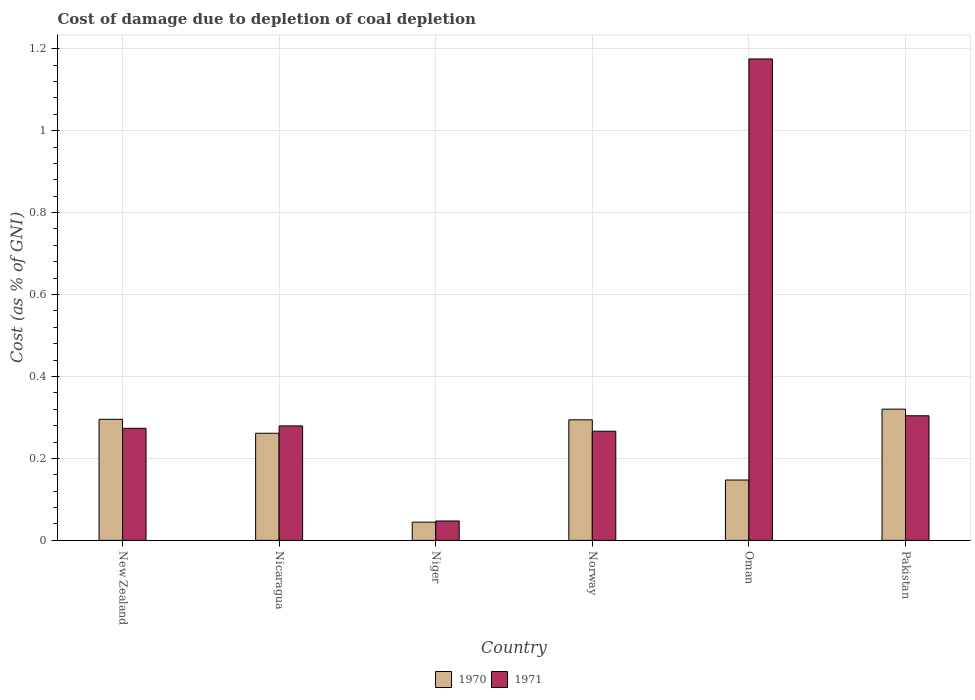How many groups of bars are there?
Provide a short and direct response. 6. Are the number of bars on each tick of the X-axis equal?
Offer a terse response. Yes. What is the label of the 5th group of bars from the left?
Offer a very short reply. Oman. What is the cost of damage caused due to coal depletion in 1970 in Pakistan?
Offer a terse response. 0.32. Across all countries, what is the maximum cost of damage caused due to coal depletion in 1970?
Give a very brief answer. 0.32. Across all countries, what is the minimum cost of damage caused due to coal depletion in 1971?
Your answer should be compact. 0.05. In which country was the cost of damage caused due to coal depletion in 1971 maximum?
Your response must be concise. Oman. In which country was the cost of damage caused due to coal depletion in 1970 minimum?
Ensure brevity in your answer.  Niger. What is the total cost of damage caused due to coal depletion in 1971 in the graph?
Make the answer very short. 2.35. What is the difference between the cost of damage caused due to coal depletion in 1971 in Norway and that in Pakistan?
Make the answer very short. -0.04. What is the difference between the cost of damage caused due to coal depletion in 1970 in Norway and the cost of damage caused due to coal depletion in 1971 in Niger?
Ensure brevity in your answer.  0.25. What is the average cost of damage caused due to coal depletion in 1971 per country?
Your answer should be compact. 0.39. What is the difference between the cost of damage caused due to coal depletion of/in 1971 and cost of damage caused due to coal depletion of/in 1970 in New Zealand?
Provide a succinct answer. -0.02. What is the ratio of the cost of damage caused due to coal depletion in 1970 in Nicaragua to that in Pakistan?
Give a very brief answer. 0.82. Is the cost of damage caused due to coal depletion in 1970 in Niger less than that in Pakistan?
Your answer should be very brief. Yes. What is the difference between the highest and the second highest cost of damage caused due to coal depletion in 1970?
Offer a very short reply. 0.02. What is the difference between the highest and the lowest cost of damage caused due to coal depletion in 1971?
Your answer should be compact. 1.13. What does the 2nd bar from the left in Niger represents?
Give a very brief answer. 1971. How many bars are there?
Your answer should be compact. 12. What is the difference between two consecutive major ticks on the Y-axis?
Your answer should be very brief. 0.2. Are the values on the major ticks of Y-axis written in scientific E-notation?
Provide a short and direct response. No. How many legend labels are there?
Keep it short and to the point. 2. What is the title of the graph?
Provide a short and direct response. Cost of damage due to depletion of coal depletion. Does "1974" appear as one of the legend labels in the graph?
Ensure brevity in your answer.  No. What is the label or title of the Y-axis?
Provide a short and direct response. Cost (as % of GNI). What is the Cost (as % of GNI) in 1970 in New Zealand?
Offer a terse response. 0.3. What is the Cost (as % of GNI) in 1971 in New Zealand?
Your answer should be compact. 0.27. What is the Cost (as % of GNI) of 1970 in Nicaragua?
Offer a terse response. 0.26. What is the Cost (as % of GNI) in 1971 in Nicaragua?
Provide a succinct answer. 0.28. What is the Cost (as % of GNI) in 1970 in Niger?
Your response must be concise. 0.04. What is the Cost (as % of GNI) in 1971 in Niger?
Keep it short and to the point. 0.05. What is the Cost (as % of GNI) in 1970 in Norway?
Your response must be concise. 0.29. What is the Cost (as % of GNI) in 1971 in Norway?
Your answer should be compact. 0.27. What is the Cost (as % of GNI) in 1970 in Oman?
Offer a very short reply. 0.15. What is the Cost (as % of GNI) of 1971 in Oman?
Give a very brief answer. 1.17. What is the Cost (as % of GNI) of 1970 in Pakistan?
Provide a short and direct response. 0.32. What is the Cost (as % of GNI) in 1971 in Pakistan?
Provide a succinct answer. 0.3. Across all countries, what is the maximum Cost (as % of GNI) of 1970?
Ensure brevity in your answer.  0.32. Across all countries, what is the maximum Cost (as % of GNI) of 1971?
Your answer should be compact. 1.17. Across all countries, what is the minimum Cost (as % of GNI) of 1970?
Offer a very short reply. 0.04. Across all countries, what is the minimum Cost (as % of GNI) of 1971?
Your answer should be very brief. 0.05. What is the total Cost (as % of GNI) in 1970 in the graph?
Provide a succinct answer. 1.36. What is the total Cost (as % of GNI) of 1971 in the graph?
Offer a very short reply. 2.35. What is the difference between the Cost (as % of GNI) of 1970 in New Zealand and that in Nicaragua?
Make the answer very short. 0.03. What is the difference between the Cost (as % of GNI) in 1971 in New Zealand and that in Nicaragua?
Ensure brevity in your answer.  -0.01. What is the difference between the Cost (as % of GNI) in 1970 in New Zealand and that in Niger?
Your response must be concise. 0.25. What is the difference between the Cost (as % of GNI) of 1971 in New Zealand and that in Niger?
Offer a very short reply. 0.23. What is the difference between the Cost (as % of GNI) in 1970 in New Zealand and that in Norway?
Make the answer very short. 0. What is the difference between the Cost (as % of GNI) in 1971 in New Zealand and that in Norway?
Make the answer very short. 0.01. What is the difference between the Cost (as % of GNI) in 1970 in New Zealand and that in Oman?
Make the answer very short. 0.15. What is the difference between the Cost (as % of GNI) in 1971 in New Zealand and that in Oman?
Keep it short and to the point. -0.9. What is the difference between the Cost (as % of GNI) of 1970 in New Zealand and that in Pakistan?
Provide a short and direct response. -0.02. What is the difference between the Cost (as % of GNI) in 1971 in New Zealand and that in Pakistan?
Offer a very short reply. -0.03. What is the difference between the Cost (as % of GNI) of 1970 in Nicaragua and that in Niger?
Your answer should be compact. 0.22. What is the difference between the Cost (as % of GNI) in 1971 in Nicaragua and that in Niger?
Give a very brief answer. 0.23. What is the difference between the Cost (as % of GNI) of 1970 in Nicaragua and that in Norway?
Give a very brief answer. -0.03. What is the difference between the Cost (as % of GNI) in 1971 in Nicaragua and that in Norway?
Give a very brief answer. 0.01. What is the difference between the Cost (as % of GNI) in 1970 in Nicaragua and that in Oman?
Your answer should be very brief. 0.11. What is the difference between the Cost (as % of GNI) of 1971 in Nicaragua and that in Oman?
Provide a succinct answer. -0.9. What is the difference between the Cost (as % of GNI) in 1970 in Nicaragua and that in Pakistan?
Provide a short and direct response. -0.06. What is the difference between the Cost (as % of GNI) of 1971 in Nicaragua and that in Pakistan?
Provide a short and direct response. -0.02. What is the difference between the Cost (as % of GNI) of 1970 in Niger and that in Norway?
Give a very brief answer. -0.25. What is the difference between the Cost (as % of GNI) in 1971 in Niger and that in Norway?
Your answer should be very brief. -0.22. What is the difference between the Cost (as % of GNI) of 1970 in Niger and that in Oman?
Your answer should be compact. -0.1. What is the difference between the Cost (as % of GNI) of 1971 in Niger and that in Oman?
Your answer should be very brief. -1.13. What is the difference between the Cost (as % of GNI) in 1970 in Niger and that in Pakistan?
Your answer should be compact. -0.28. What is the difference between the Cost (as % of GNI) of 1971 in Niger and that in Pakistan?
Make the answer very short. -0.26. What is the difference between the Cost (as % of GNI) of 1970 in Norway and that in Oman?
Provide a succinct answer. 0.15. What is the difference between the Cost (as % of GNI) of 1971 in Norway and that in Oman?
Your answer should be compact. -0.91. What is the difference between the Cost (as % of GNI) in 1970 in Norway and that in Pakistan?
Make the answer very short. -0.03. What is the difference between the Cost (as % of GNI) of 1971 in Norway and that in Pakistan?
Your answer should be very brief. -0.04. What is the difference between the Cost (as % of GNI) in 1970 in Oman and that in Pakistan?
Provide a succinct answer. -0.17. What is the difference between the Cost (as % of GNI) in 1971 in Oman and that in Pakistan?
Make the answer very short. 0.87. What is the difference between the Cost (as % of GNI) in 1970 in New Zealand and the Cost (as % of GNI) in 1971 in Nicaragua?
Provide a short and direct response. 0.02. What is the difference between the Cost (as % of GNI) of 1970 in New Zealand and the Cost (as % of GNI) of 1971 in Niger?
Provide a short and direct response. 0.25. What is the difference between the Cost (as % of GNI) in 1970 in New Zealand and the Cost (as % of GNI) in 1971 in Norway?
Your answer should be very brief. 0.03. What is the difference between the Cost (as % of GNI) in 1970 in New Zealand and the Cost (as % of GNI) in 1971 in Oman?
Give a very brief answer. -0.88. What is the difference between the Cost (as % of GNI) of 1970 in New Zealand and the Cost (as % of GNI) of 1971 in Pakistan?
Keep it short and to the point. -0.01. What is the difference between the Cost (as % of GNI) in 1970 in Nicaragua and the Cost (as % of GNI) in 1971 in Niger?
Offer a very short reply. 0.21. What is the difference between the Cost (as % of GNI) of 1970 in Nicaragua and the Cost (as % of GNI) of 1971 in Norway?
Keep it short and to the point. -0. What is the difference between the Cost (as % of GNI) in 1970 in Nicaragua and the Cost (as % of GNI) in 1971 in Oman?
Your answer should be compact. -0.91. What is the difference between the Cost (as % of GNI) in 1970 in Nicaragua and the Cost (as % of GNI) in 1971 in Pakistan?
Your response must be concise. -0.04. What is the difference between the Cost (as % of GNI) of 1970 in Niger and the Cost (as % of GNI) of 1971 in Norway?
Provide a short and direct response. -0.22. What is the difference between the Cost (as % of GNI) of 1970 in Niger and the Cost (as % of GNI) of 1971 in Oman?
Offer a terse response. -1.13. What is the difference between the Cost (as % of GNI) of 1970 in Niger and the Cost (as % of GNI) of 1971 in Pakistan?
Give a very brief answer. -0.26. What is the difference between the Cost (as % of GNI) of 1970 in Norway and the Cost (as % of GNI) of 1971 in Oman?
Ensure brevity in your answer.  -0.88. What is the difference between the Cost (as % of GNI) in 1970 in Norway and the Cost (as % of GNI) in 1971 in Pakistan?
Make the answer very short. -0.01. What is the difference between the Cost (as % of GNI) in 1970 in Oman and the Cost (as % of GNI) in 1971 in Pakistan?
Your response must be concise. -0.16. What is the average Cost (as % of GNI) in 1970 per country?
Your answer should be compact. 0.23. What is the average Cost (as % of GNI) in 1971 per country?
Give a very brief answer. 0.39. What is the difference between the Cost (as % of GNI) in 1970 and Cost (as % of GNI) in 1971 in New Zealand?
Provide a short and direct response. 0.02. What is the difference between the Cost (as % of GNI) in 1970 and Cost (as % of GNI) in 1971 in Nicaragua?
Your answer should be compact. -0.02. What is the difference between the Cost (as % of GNI) in 1970 and Cost (as % of GNI) in 1971 in Niger?
Offer a terse response. -0. What is the difference between the Cost (as % of GNI) of 1970 and Cost (as % of GNI) of 1971 in Norway?
Ensure brevity in your answer.  0.03. What is the difference between the Cost (as % of GNI) in 1970 and Cost (as % of GNI) in 1971 in Oman?
Your answer should be very brief. -1.03. What is the difference between the Cost (as % of GNI) of 1970 and Cost (as % of GNI) of 1971 in Pakistan?
Offer a very short reply. 0.02. What is the ratio of the Cost (as % of GNI) of 1970 in New Zealand to that in Nicaragua?
Offer a very short reply. 1.13. What is the ratio of the Cost (as % of GNI) in 1971 in New Zealand to that in Nicaragua?
Ensure brevity in your answer.  0.98. What is the ratio of the Cost (as % of GNI) of 1970 in New Zealand to that in Niger?
Give a very brief answer. 6.63. What is the ratio of the Cost (as % of GNI) in 1971 in New Zealand to that in Niger?
Make the answer very short. 5.78. What is the ratio of the Cost (as % of GNI) in 1971 in New Zealand to that in Norway?
Your response must be concise. 1.03. What is the ratio of the Cost (as % of GNI) of 1970 in New Zealand to that in Oman?
Your response must be concise. 2.01. What is the ratio of the Cost (as % of GNI) in 1971 in New Zealand to that in Oman?
Provide a short and direct response. 0.23. What is the ratio of the Cost (as % of GNI) in 1970 in New Zealand to that in Pakistan?
Ensure brevity in your answer.  0.92. What is the ratio of the Cost (as % of GNI) in 1971 in New Zealand to that in Pakistan?
Provide a short and direct response. 0.9. What is the ratio of the Cost (as % of GNI) of 1970 in Nicaragua to that in Niger?
Provide a succinct answer. 5.87. What is the ratio of the Cost (as % of GNI) of 1971 in Nicaragua to that in Niger?
Ensure brevity in your answer.  5.9. What is the ratio of the Cost (as % of GNI) of 1970 in Nicaragua to that in Norway?
Offer a terse response. 0.89. What is the ratio of the Cost (as % of GNI) in 1971 in Nicaragua to that in Norway?
Make the answer very short. 1.05. What is the ratio of the Cost (as % of GNI) of 1970 in Nicaragua to that in Oman?
Your answer should be compact. 1.77. What is the ratio of the Cost (as % of GNI) of 1971 in Nicaragua to that in Oman?
Provide a succinct answer. 0.24. What is the ratio of the Cost (as % of GNI) of 1970 in Nicaragua to that in Pakistan?
Make the answer very short. 0.82. What is the ratio of the Cost (as % of GNI) in 1971 in Nicaragua to that in Pakistan?
Offer a terse response. 0.92. What is the ratio of the Cost (as % of GNI) of 1970 in Niger to that in Norway?
Give a very brief answer. 0.15. What is the ratio of the Cost (as % of GNI) of 1971 in Niger to that in Norway?
Provide a succinct answer. 0.18. What is the ratio of the Cost (as % of GNI) in 1970 in Niger to that in Oman?
Offer a very short reply. 0.3. What is the ratio of the Cost (as % of GNI) of 1971 in Niger to that in Oman?
Ensure brevity in your answer.  0.04. What is the ratio of the Cost (as % of GNI) in 1970 in Niger to that in Pakistan?
Your answer should be very brief. 0.14. What is the ratio of the Cost (as % of GNI) of 1971 in Niger to that in Pakistan?
Your response must be concise. 0.16. What is the ratio of the Cost (as % of GNI) in 1970 in Norway to that in Oman?
Offer a very short reply. 2. What is the ratio of the Cost (as % of GNI) of 1971 in Norway to that in Oman?
Your answer should be compact. 0.23. What is the ratio of the Cost (as % of GNI) in 1970 in Norway to that in Pakistan?
Your answer should be very brief. 0.92. What is the ratio of the Cost (as % of GNI) of 1971 in Norway to that in Pakistan?
Offer a very short reply. 0.88. What is the ratio of the Cost (as % of GNI) of 1970 in Oman to that in Pakistan?
Your answer should be very brief. 0.46. What is the ratio of the Cost (as % of GNI) in 1971 in Oman to that in Pakistan?
Provide a succinct answer. 3.86. What is the difference between the highest and the second highest Cost (as % of GNI) of 1970?
Make the answer very short. 0.02. What is the difference between the highest and the second highest Cost (as % of GNI) of 1971?
Your answer should be very brief. 0.87. What is the difference between the highest and the lowest Cost (as % of GNI) in 1970?
Offer a very short reply. 0.28. What is the difference between the highest and the lowest Cost (as % of GNI) of 1971?
Your answer should be very brief. 1.13. 